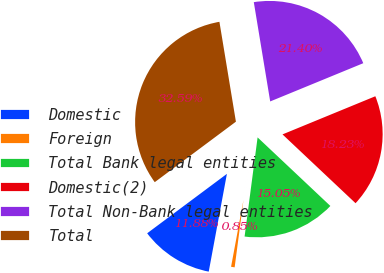Convert chart. <chart><loc_0><loc_0><loc_500><loc_500><pie_chart><fcel>Domestic<fcel>Foreign<fcel>Total Bank legal entities<fcel>Domestic(2)<fcel>Total Non-Bank legal entities<fcel>Total<nl><fcel>11.88%<fcel>0.85%<fcel>15.05%<fcel>18.23%<fcel>21.4%<fcel>32.59%<nl></chart> 